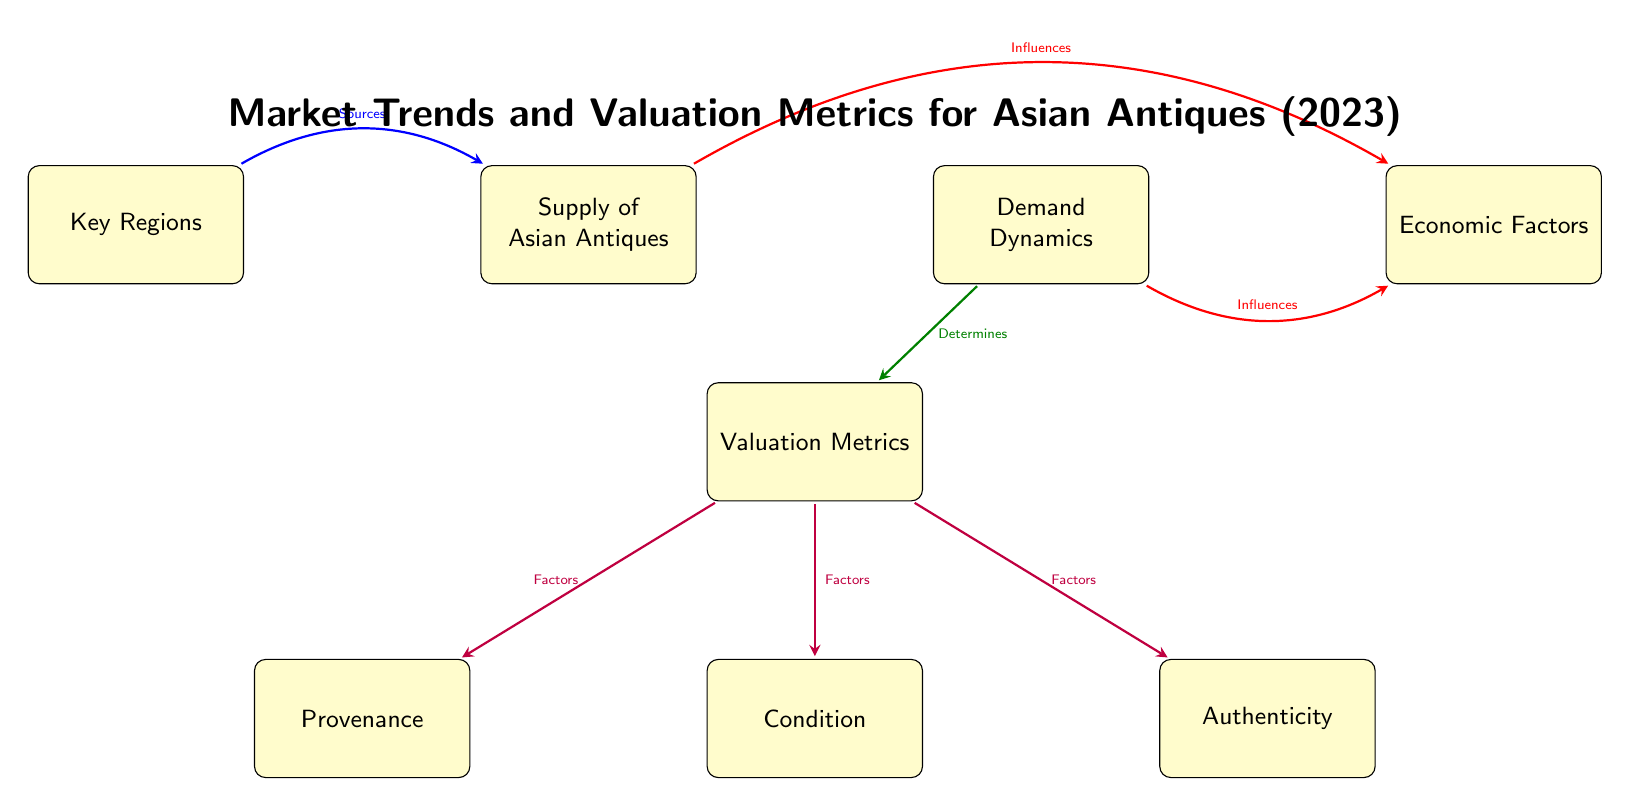What are the three valuation factors listed in the diagram? The diagram indicates three specific valuation factors branching from the "Valuation Metrics" node: "Provenance," "Condition," and "Authenticity." These are the only three factors explicitly stated in the visual.
Answer: Provenance, Condition, Authenticity How many total boxes are there in the diagram? By counting the distinct boxes shown in the diagram, we can find there are eight boxes, which include "Supply of Asian Antiques," "Demand Dynamics," "Valuation Metrics," "Key Regions," "Economic Factors," "Provenance," "Condition," and "Authenticity."
Answer: 8 What influences the "Economic Factors"? The "Economic Factors" in the diagram are influenced by two nodes: "Supply of Asian Antiques" and "Demand Dynamics." Arrows indicate a bidirectional relationship, confirming that they affect economic conditions simultaneously.
Answer: Supply of Asian Antiques, Demand Dynamics Which node determines the "Valuation Metrics"? The diagram shows that the box representing "Demand Dynamics" directly points to "Valuation Metrics" with an arrow labeled "Determines." This indicates that the demand dynamics play a critical role in determining how Asian antiques are valued.
Answer: Demand Dynamics What are the sources of the "Supply of Asian Antiques"? The "Supply of Asian Antiques" node is sourced from the "Key Regions" box, as indicated by the arrow labeled "Sources" that connects the two nodes. This implies that different key regions contribute to the supply of Asian antiques.
Answer: Key Regions How many factors contribute to the "Valuation Metrics"? The "Valuation Metrics" box has three direct branches representing contributing factors: "Provenance," "Condition," and "Authenticity." Each of these branches indicates a specific aspect that affects valuation.
Answer: 3 Which node does the "Key Regions" influence? The "Key Regions" node has a direct influence on the "Supply of Asian Antiques" according to the arrow that connects them, labeled "Sources." Therefore, states of key regions are critical for supply levels.
Answer: Supply of Asian Antiques What is the color of the arrow that connects "Demand Dynamics" to "Valuation Metrics"? The arrow linking "Demand Dynamics" to "Valuation Metrics" is green, as shown in the visual representation. This color coding is used to indicate the relationship type within the diagram.
Answer: Green 